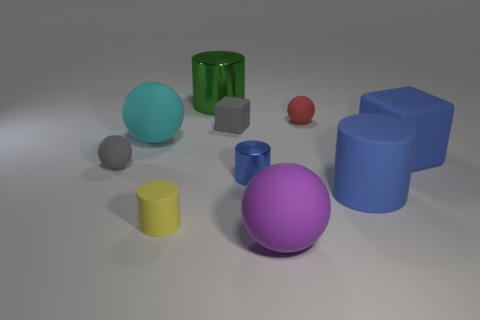Is the shadow cast by the blue cylinder indicative of the light source's direction, and what can it tell us about the setup of the scene? Yes, the shadow of the blue cylinder extends towards the upper right corner of the image, suggesting that the light source is positioned to the lower left of the scene. This setup directs soft, diffused lighting across the arrangement of objects, highlighting their colors and shapes with subtle shadowing that adds depth and dimension to the visual composition. 